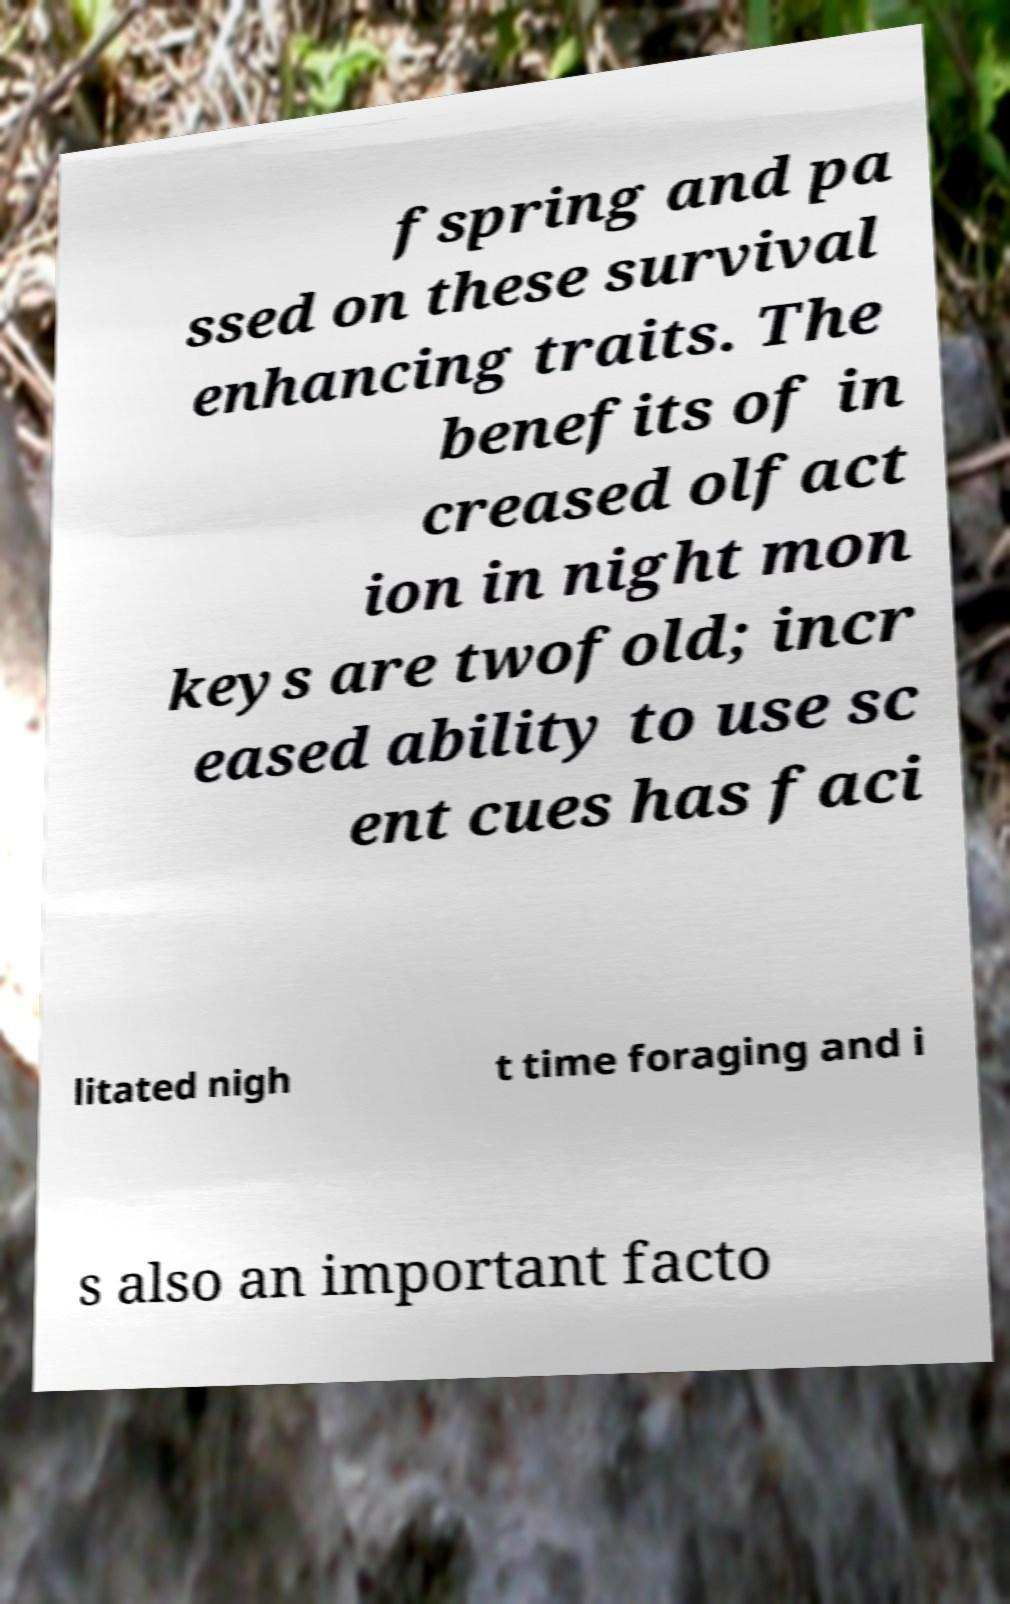Can you read and provide the text displayed in the image?This photo seems to have some interesting text. Can you extract and type it out for me? fspring and pa ssed on these survival enhancing traits. The benefits of in creased olfact ion in night mon keys are twofold; incr eased ability to use sc ent cues has faci litated nigh t time foraging and i s also an important facto 